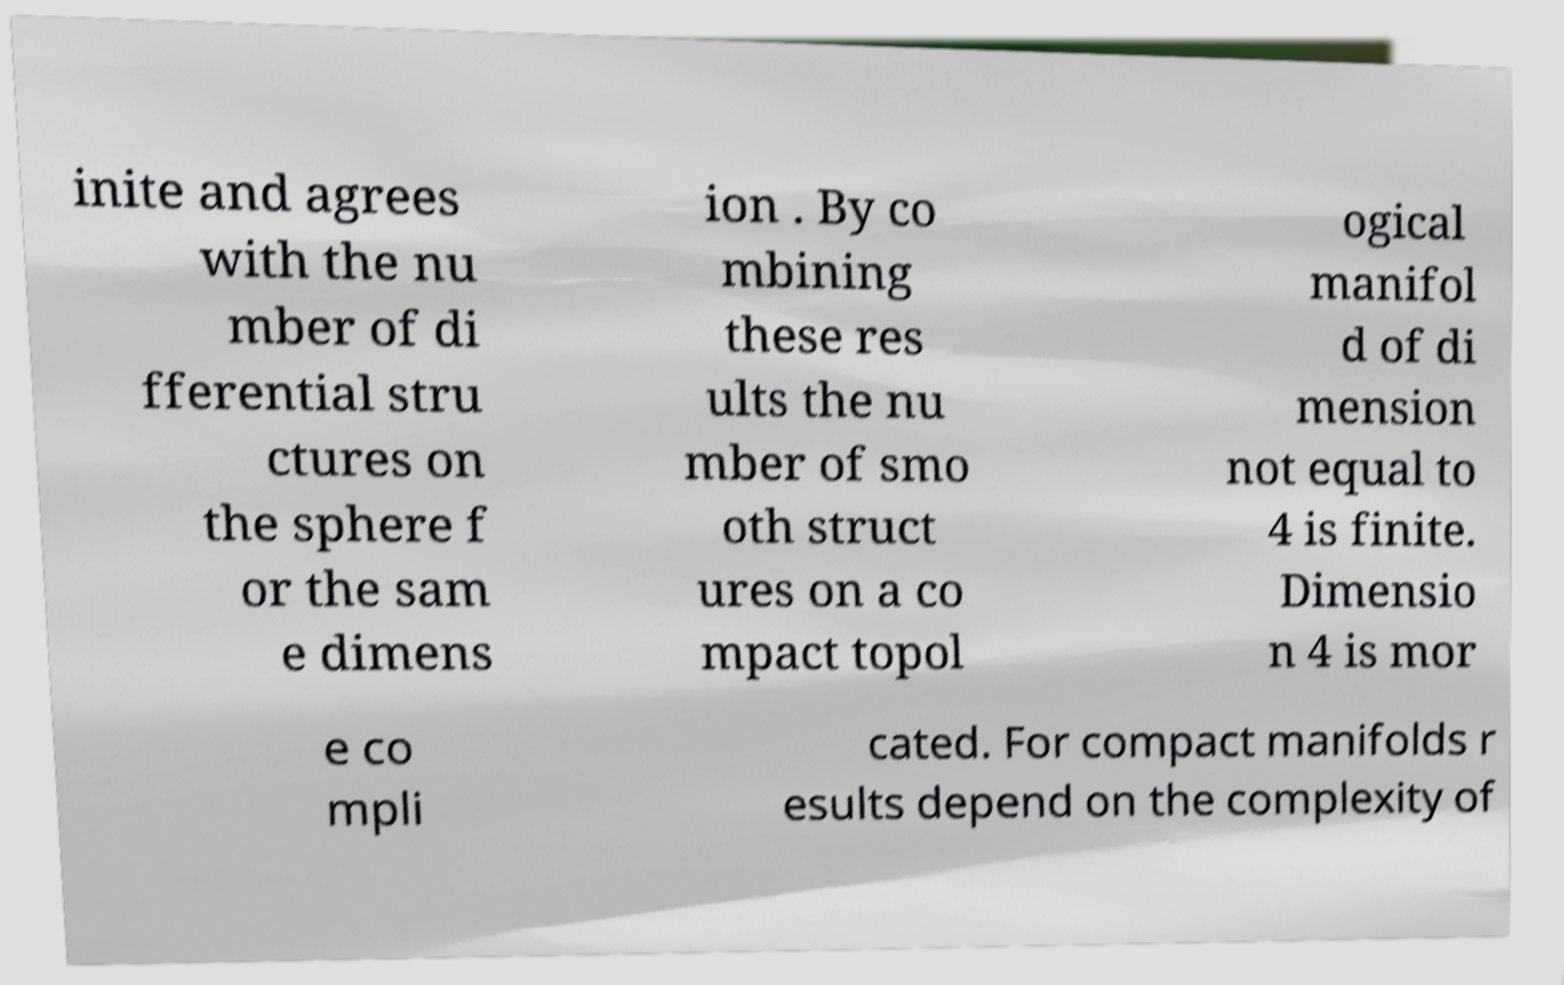Please identify and transcribe the text found in this image. inite and agrees with the nu mber of di fferential stru ctures on the sphere f or the sam e dimens ion . By co mbining these res ults the nu mber of smo oth struct ures on a co mpact topol ogical manifol d of di mension not equal to 4 is finite. Dimensio n 4 is mor e co mpli cated. For compact manifolds r esults depend on the complexity of 